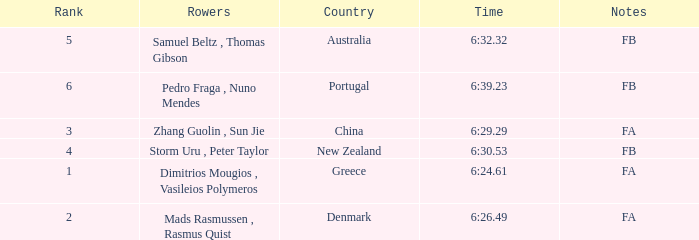What country has a rank smaller than 6, a time of 6:32.32 and notes of FB? Australia. 